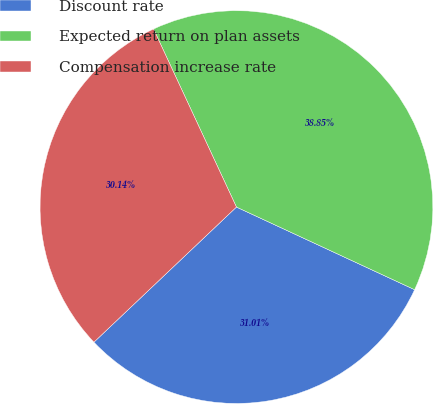Convert chart. <chart><loc_0><loc_0><loc_500><loc_500><pie_chart><fcel>Discount rate<fcel>Expected return on plan assets<fcel>Compensation increase rate<nl><fcel>31.01%<fcel>38.85%<fcel>30.14%<nl></chart> 